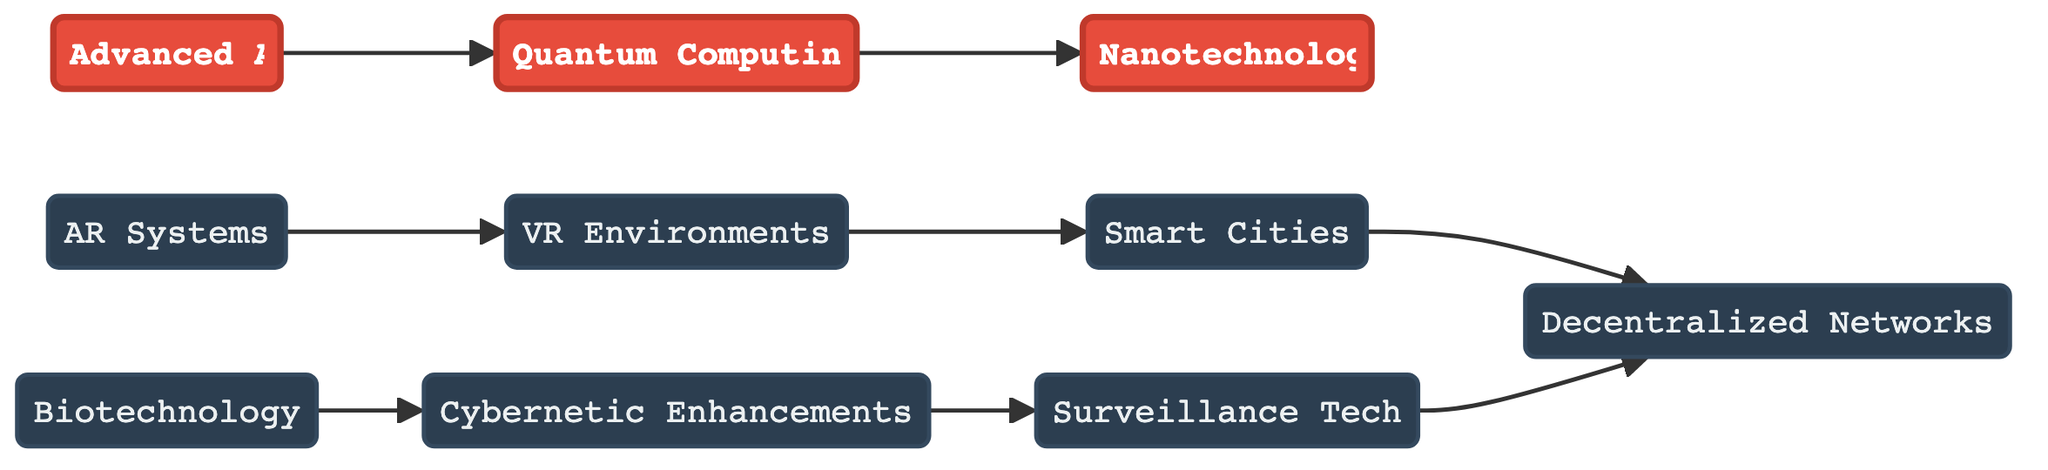What's the total number of nodes in the diagram? The diagram lists a total of 10 nodes: Advanced Artificial Intelligence, Augmented Reality Systems, Biotechnology, Quantum Computing, Cybernetic Enhancements, Nanotechnology, Virtual Reality Environments, Smart Cities, Decentralized Networks, and Surveillance Technologies.
Answer: 10 How many edges are visible in the diagram? There are 8 edges in the diagram, connecting the various nodes, as indicated by the connections between them.
Answer: 8 What does the node "5" represent? In the diagram, node "5" is labeled as "Cybernetic Enhancements," which indicates a specific technology area within the cyberpunk theme.
Answer: Cybernetic Enhancements Which node leads to "8"? The node "7" leads to "8," representing the connection between Virtual Reality Environments and Smart Cities in the evolution of technology.
Answer: 7 Which technologies are directly connected to "Quantum Computing"? "Quantum Computing" is directly connected to "Nanotechnology," as indicated by the directed edge from node "4" to node "6."
Answer: Nanotechnology What is the relationship between "Surveillance Technologies" and "Decentralized Networks"? "Surveillance Technologies" is a source node that connects to "Decentralized Networks," suggesting that surveillance technology feeds into or influences network decentralization.
Answer: Influences How many nodes are highlighted in the diagram? There are 3 highlighted nodes: "Advanced AI," "Quantum Computing," and "Nanotechnology." The highlight indicates their importance.
Answer: 3 Identify the pathway leading from "Advanced Artificial Intelligence" to "Smart Cities." The pathway begins at "Advanced AI," which connects to "Quantum Computing," then "Nanotechnology," followed by "Cybernetic Enhancements," and ends at "Smart Cities" through "Virtual Reality Environments."
Answer: Advanced AI → Quantum Computing → Nanotechnology → Cybernetic Enhancements → Virtual Reality Environments → Smart Cities Which node has incoming edges from "5" and "10"? The node "9," labeled as "Decentralized Networks," has incoming edges from both "Cybernetic Enhancements" (node "5") and "Surveillance Technologies" (node "10").
Answer: Decentralized Networks 